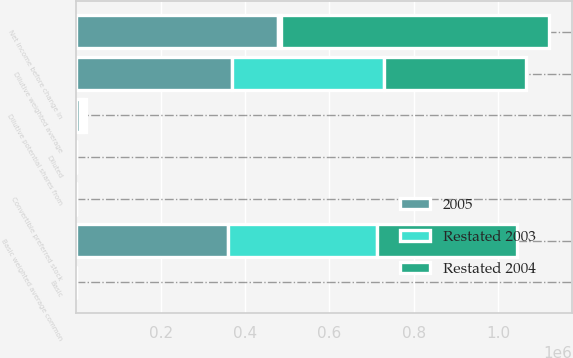Convert chart to OTSL. <chart><loc_0><loc_0><loc_500><loc_500><stacked_bar_chart><ecel><fcel>Net income before change in<fcel>Basic weighted average common<fcel>Dilutive potential shares from<fcel>Convertible preferred stock<fcel>Dilutive weighted average<fcel>Basic<fcel>Diluted<nl><fcel>Restated 2004<fcel>635857<fcel>331612<fcel>6012<fcel>1<fcel>337625<fcel>1.92<fcel>1.88<nl><fcel>Restated 2003<fcel>6731<fcel>354152<fcel>7450<fcel>1<fcel>361603<fcel>2.02<fcel>1.98<nl><fcel>2005<fcel>477615<fcel>359276<fcel>8878<fcel>1<fcel>368155<fcel>1.33<fcel>1.3<nl></chart> 